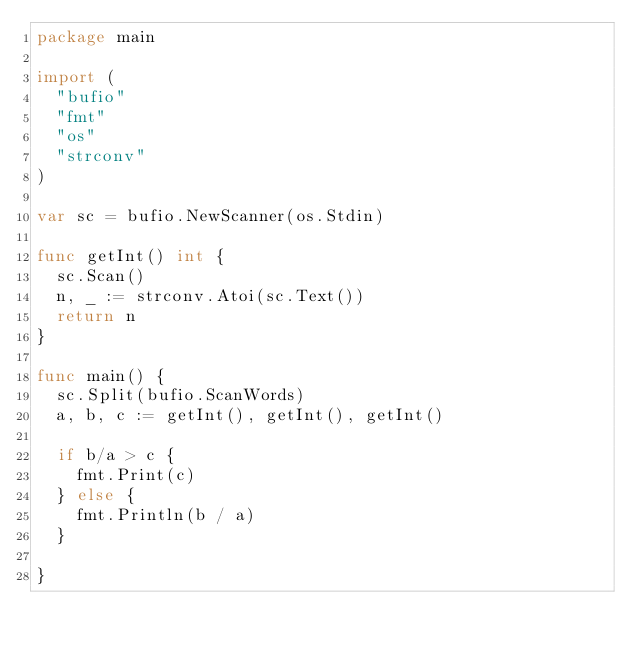Convert code to text. <code><loc_0><loc_0><loc_500><loc_500><_Go_>package main

import (
	"bufio"
	"fmt"
	"os"
	"strconv"
)

var sc = bufio.NewScanner(os.Stdin)

func getInt() int {
	sc.Scan()
	n, _ := strconv.Atoi(sc.Text())
	return n
}

func main() {
	sc.Split(bufio.ScanWords)
	a, b, c := getInt(), getInt(), getInt()

	if b/a > c {
		fmt.Print(c)
	} else {
		fmt.Println(b / a)
	}

}
</code> 